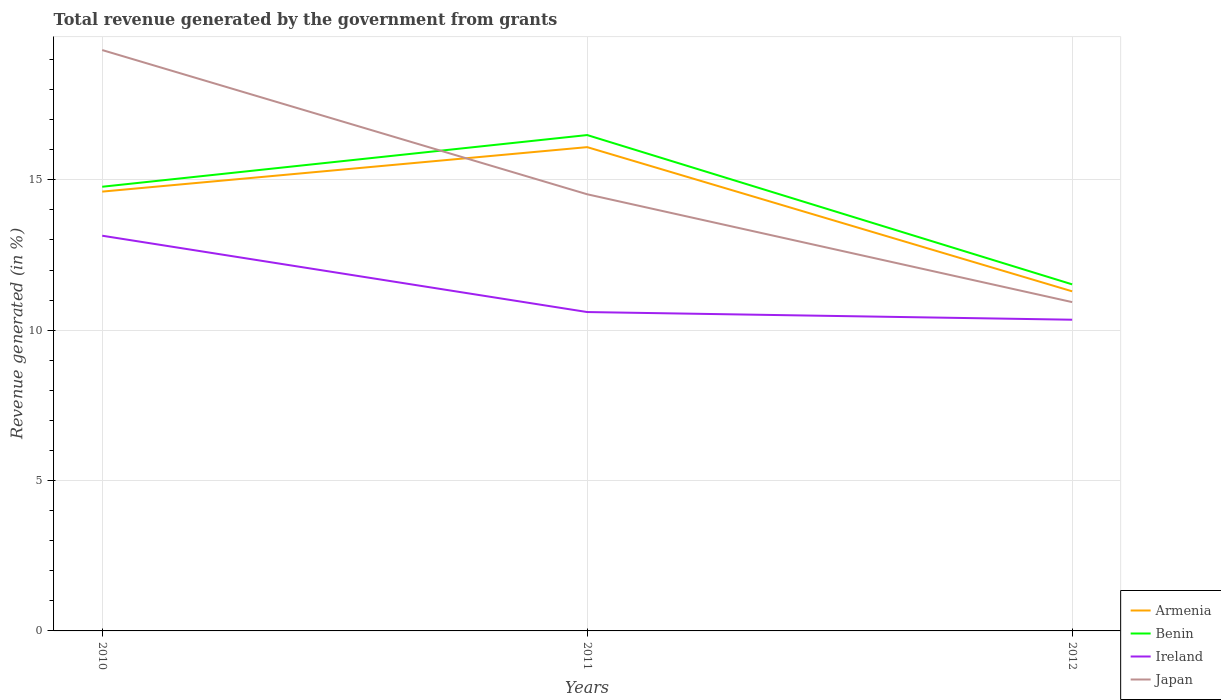How many different coloured lines are there?
Give a very brief answer. 4. Across all years, what is the maximum total revenue generated in Armenia?
Provide a short and direct response. 11.29. In which year was the total revenue generated in Benin maximum?
Your answer should be very brief. 2012. What is the total total revenue generated in Benin in the graph?
Provide a short and direct response. 3.25. What is the difference between the highest and the second highest total revenue generated in Ireland?
Your answer should be very brief. 2.79. What is the difference between the highest and the lowest total revenue generated in Japan?
Keep it short and to the point. 1. Is the total revenue generated in Benin strictly greater than the total revenue generated in Ireland over the years?
Keep it short and to the point. No. Does the graph contain any zero values?
Ensure brevity in your answer.  No. How many legend labels are there?
Provide a short and direct response. 4. How are the legend labels stacked?
Your answer should be compact. Vertical. What is the title of the graph?
Keep it short and to the point. Total revenue generated by the government from grants. Does "Middle East & North Africa (all income levels)" appear as one of the legend labels in the graph?
Ensure brevity in your answer.  No. What is the label or title of the Y-axis?
Offer a terse response. Revenue generated (in %). What is the Revenue generated (in %) in Armenia in 2010?
Keep it short and to the point. 14.61. What is the Revenue generated (in %) in Benin in 2010?
Provide a succinct answer. 14.77. What is the Revenue generated (in %) in Ireland in 2010?
Offer a very short reply. 13.14. What is the Revenue generated (in %) of Japan in 2010?
Provide a succinct answer. 19.31. What is the Revenue generated (in %) in Armenia in 2011?
Offer a terse response. 16.09. What is the Revenue generated (in %) of Benin in 2011?
Offer a very short reply. 16.49. What is the Revenue generated (in %) of Ireland in 2011?
Your answer should be compact. 10.6. What is the Revenue generated (in %) in Japan in 2011?
Your response must be concise. 14.52. What is the Revenue generated (in %) in Armenia in 2012?
Make the answer very short. 11.29. What is the Revenue generated (in %) of Benin in 2012?
Make the answer very short. 11.52. What is the Revenue generated (in %) in Ireland in 2012?
Give a very brief answer. 10.35. What is the Revenue generated (in %) in Japan in 2012?
Keep it short and to the point. 10.93. Across all years, what is the maximum Revenue generated (in %) in Armenia?
Provide a short and direct response. 16.09. Across all years, what is the maximum Revenue generated (in %) in Benin?
Offer a very short reply. 16.49. Across all years, what is the maximum Revenue generated (in %) in Ireland?
Provide a short and direct response. 13.14. Across all years, what is the maximum Revenue generated (in %) of Japan?
Provide a short and direct response. 19.31. Across all years, what is the minimum Revenue generated (in %) of Armenia?
Offer a very short reply. 11.29. Across all years, what is the minimum Revenue generated (in %) in Benin?
Offer a very short reply. 11.52. Across all years, what is the minimum Revenue generated (in %) of Ireland?
Your response must be concise. 10.35. Across all years, what is the minimum Revenue generated (in %) in Japan?
Give a very brief answer. 10.93. What is the total Revenue generated (in %) in Armenia in the graph?
Your response must be concise. 41.99. What is the total Revenue generated (in %) in Benin in the graph?
Ensure brevity in your answer.  42.78. What is the total Revenue generated (in %) in Ireland in the graph?
Your answer should be very brief. 34.09. What is the total Revenue generated (in %) in Japan in the graph?
Your answer should be compact. 44.77. What is the difference between the Revenue generated (in %) in Armenia in 2010 and that in 2011?
Keep it short and to the point. -1.48. What is the difference between the Revenue generated (in %) in Benin in 2010 and that in 2011?
Provide a short and direct response. -1.72. What is the difference between the Revenue generated (in %) in Ireland in 2010 and that in 2011?
Make the answer very short. 2.54. What is the difference between the Revenue generated (in %) in Japan in 2010 and that in 2011?
Make the answer very short. 4.8. What is the difference between the Revenue generated (in %) in Armenia in 2010 and that in 2012?
Make the answer very short. 3.32. What is the difference between the Revenue generated (in %) of Benin in 2010 and that in 2012?
Provide a short and direct response. 3.25. What is the difference between the Revenue generated (in %) of Ireland in 2010 and that in 2012?
Give a very brief answer. 2.79. What is the difference between the Revenue generated (in %) in Japan in 2010 and that in 2012?
Ensure brevity in your answer.  8.38. What is the difference between the Revenue generated (in %) of Armenia in 2011 and that in 2012?
Your response must be concise. 4.79. What is the difference between the Revenue generated (in %) of Benin in 2011 and that in 2012?
Offer a terse response. 4.96. What is the difference between the Revenue generated (in %) of Ireland in 2011 and that in 2012?
Provide a short and direct response. 0.25. What is the difference between the Revenue generated (in %) in Japan in 2011 and that in 2012?
Offer a very short reply. 3.59. What is the difference between the Revenue generated (in %) of Armenia in 2010 and the Revenue generated (in %) of Benin in 2011?
Offer a terse response. -1.88. What is the difference between the Revenue generated (in %) of Armenia in 2010 and the Revenue generated (in %) of Ireland in 2011?
Provide a short and direct response. 4. What is the difference between the Revenue generated (in %) in Armenia in 2010 and the Revenue generated (in %) in Japan in 2011?
Offer a terse response. 0.09. What is the difference between the Revenue generated (in %) in Benin in 2010 and the Revenue generated (in %) in Ireland in 2011?
Offer a very short reply. 4.17. What is the difference between the Revenue generated (in %) in Benin in 2010 and the Revenue generated (in %) in Japan in 2011?
Keep it short and to the point. 0.25. What is the difference between the Revenue generated (in %) in Ireland in 2010 and the Revenue generated (in %) in Japan in 2011?
Provide a succinct answer. -1.38. What is the difference between the Revenue generated (in %) of Armenia in 2010 and the Revenue generated (in %) of Benin in 2012?
Your response must be concise. 3.08. What is the difference between the Revenue generated (in %) of Armenia in 2010 and the Revenue generated (in %) of Ireland in 2012?
Ensure brevity in your answer.  4.26. What is the difference between the Revenue generated (in %) in Armenia in 2010 and the Revenue generated (in %) in Japan in 2012?
Provide a short and direct response. 3.67. What is the difference between the Revenue generated (in %) of Benin in 2010 and the Revenue generated (in %) of Ireland in 2012?
Ensure brevity in your answer.  4.42. What is the difference between the Revenue generated (in %) in Benin in 2010 and the Revenue generated (in %) in Japan in 2012?
Offer a terse response. 3.84. What is the difference between the Revenue generated (in %) in Ireland in 2010 and the Revenue generated (in %) in Japan in 2012?
Provide a short and direct response. 2.21. What is the difference between the Revenue generated (in %) in Armenia in 2011 and the Revenue generated (in %) in Benin in 2012?
Ensure brevity in your answer.  4.56. What is the difference between the Revenue generated (in %) of Armenia in 2011 and the Revenue generated (in %) of Ireland in 2012?
Your answer should be very brief. 5.74. What is the difference between the Revenue generated (in %) of Armenia in 2011 and the Revenue generated (in %) of Japan in 2012?
Provide a succinct answer. 5.15. What is the difference between the Revenue generated (in %) in Benin in 2011 and the Revenue generated (in %) in Ireland in 2012?
Your answer should be compact. 6.14. What is the difference between the Revenue generated (in %) in Benin in 2011 and the Revenue generated (in %) in Japan in 2012?
Offer a terse response. 5.55. What is the difference between the Revenue generated (in %) in Ireland in 2011 and the Revenue generated (in %) in Japan in 2012?
Your answer should be compact. -0.33. What is the average Revenue generated (in %) in Armenia per year?
Provide a succinct answer. 14. What is the average Revenue generated (in %) of Benin per year?
Your response must be concise. 14.26. What is the average Revenue generated (in %) of Ireland per year?
Your response must be concise. 11.36. What is the average Revenue generated (in %) of Japan per year?
Give a very brief answer. 14.92. In the year 2010, what is the difference between the Revenue generated (in %) of Armenia and Revenue generated (in %) of Benin?
Offer a very short reply. -0.16. In the year 2010, what is the difference between the Revenue generated (in %) of Armenia and Revenue generated (in %) of Ireland?
Keep it short and to the point. 1.47. In the year 2010, what is the difference between the Revenue generated (in %) of Armenia and Revenue generated (in %) of Japan?
Provide a short and direct response. -4.71. In the year 2010, what is the difference between the Revenue generated (in %) in Benin and Revenue generated (in %) in Ireland?
Your answer should be very brief. 1.63. In the year 2010, what is the difference between the Revenue generated (in %) in Benin and Revenue generated (in %) in Japan?
Offer a terse response. -4.54. In the year 2010, what is the difference between the Revenue generated (in %) in Ireland and Revenue generated (in %) in Japan?
Keep it short and to the point. -6.17. In the year 2011, what is the difference between the Revenue generated (in %) in Armenia and Revenue generated (in %) in Benin?
Ensure brevity in your answer.  -0.4. In the year 2011, what is the difference between the Revenue generated (in %) of Armenia and Revenue generated (in %) of Ireland?
Offer a very short reply. 5.48. In the year 2011, what is the difference between the Revenue generated (in %) of Armenia and Revenue generated (in %) of Japan?
Your answer should be very brief. 1.57. In the year 2011, what is the difference between the Revenue generated (in %) in Benin and Revenue generated (in %) in Ireland?
Your response must be concise. 5.89. In the year 2011, what is the difference between the Revenue generated (in %) in Benin and Revenue generated (in %) in Japan?
Your answer should be compact. 1.97. In the year 2011, what is the difference between the Revenue generated (in %) in Ireland and Revenue generated (in %) in Japan?
Your response must be concise. -3.92. In the year 2012, what is the difference between the Revenue generated (in %) of Armenia and Revenue generated (in %) of Benin?
Keep it short and to the point. -0.23. In the year 2012, what is the difference between the Revenue generated (in %) of Armenia and Revenue generated (in %) of Ireland?
Make the answer very short. 0.94. In the year 2012, what is the difference between the Revenue generated (in %) in Armenia and Revenue generated (in %) in Japan?
Offer a very short reply. 0.36. In the year 2012, what is the difference between the Revenue generated (in %) of Benin and Revenue generated (in %) of Ireland?
Offer a terse response. 1.18. In the year 2012, what is the difference between the Revenue generated (in %) of Benin and Revenue generated (in %) of Japan?
Your answer should be compact. 0.59. In the year 2012, what is the difference between the Revenue generated (in %) of Ireland and Revenue generated (in %) of Japan?
Your answer should be compact. -0.59. What is the ratio of the Revenue generated (in %) in Armenia in 2010 to that in 2011?
Your response must be concise. 0.91. What is the ratio of the Revenue generated (in %) of Benin in 2010 to that in 2011?
Your answer should be very brief. 0.9. What is the ratio of the Revenue generated (in %) of Ireland in 2010 to that in 2011?
Give a very brief answer. 1.24. What is the ratio of the Revenue generated (in %) in Japan in 2010 to that in 2011?
Provide a succinct answer. 1.33. What is the ratio of the Revenue generated (in %) in Armenia in 2010 to that in 2012?
Provide a succinct answer. 1.29. What is the ratio of the Revenue generated (in %) of Benin in 2010 to that in 2012?
Your answer should be very brief. 1.28. What is the ratio of the Revenue generated (in %) of Ireland in 2010 to that in 2012?
Give a very brief answer. 1.27. What is the ratio of the Revenue generated (in %) of Japan in 2010 to that in 2012?
Your answer should be compact. 1.77. What is the ratio of the Revenue generated (in %) of Armenia in 2011 to that in 2012?
Your response must be concise. 1.42. What is the ratio of the Revenue generated (in %) in Benin in 2011 to that in 2012?
Ensure brevity in your answer.  1.43. What is the ratio of the Revenue generated (in %) in Ireland in 2011 to that in 2012?
Make the answer very short. 1.02. What is the ratio of the Revenue generated (in %) in Japan in 2011 to that in 2012?
Offer a terse response. 1.33. What is the difference between the highest and the second highest Revenue generated (in %) of Armenia?
Offer a very short reply. 1.48. What is the difference between the highest and the second highest Revenue generated (in %) in Benin?
Keep it short and to the point. 1.72. What is the difference between the highest and the second highest Revenue generated (in %) of Ireland?
Offer a very short reply. 2.54. What is the difference between the highest and the second highest Revenue generated (in %) of Japan?
Keep it short and to the point. 4.8. What is the difference between the highest and the lowest Revenue generated (in %) of Armenia?
Your answer should be very brief. 4.79. What is the difference between the highest and the lowest Revenue generated (in %) in Benin?
Ensure brevity in your answer.  4.96. What is the difference between the highest and the lowest Revenue generated (in %) of Ireland?
Your response must be concise. 2.79. What is the difference between the highest and the lowest Revenue generated (in %) in Japan?
Give a very brief answer. 8.38. 